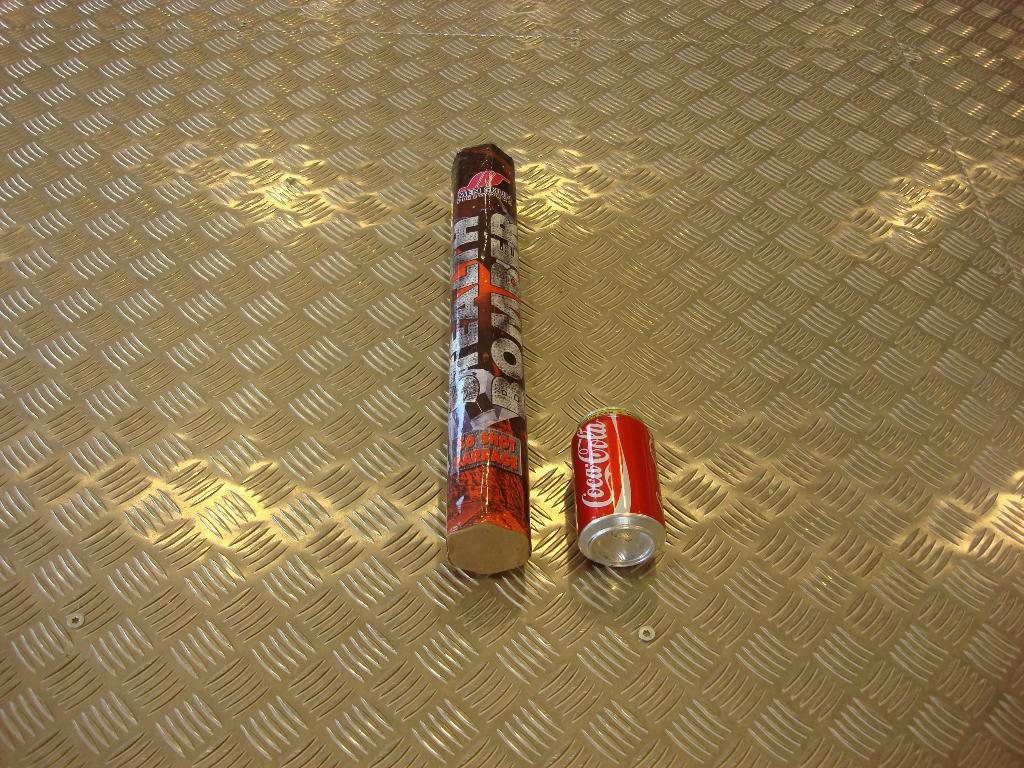<image>
Write a terse but informative summary of the picture. A can of Coca-Cola is next to a Stealth Bomber container. 